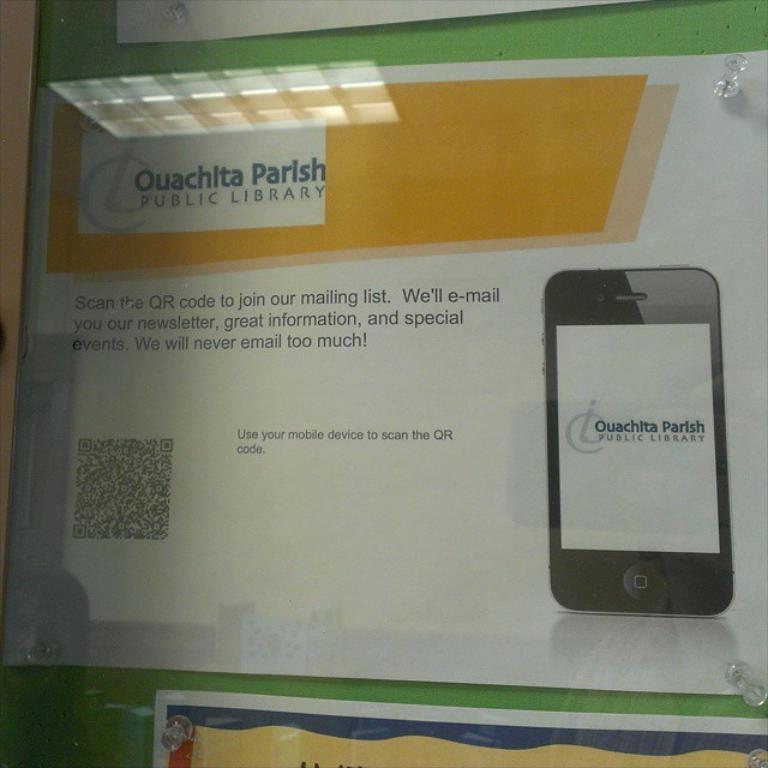<image>
Offer a succinct explanation of the picture presented. An sign to join the mailing list at Ouachita Parish Public Library. 